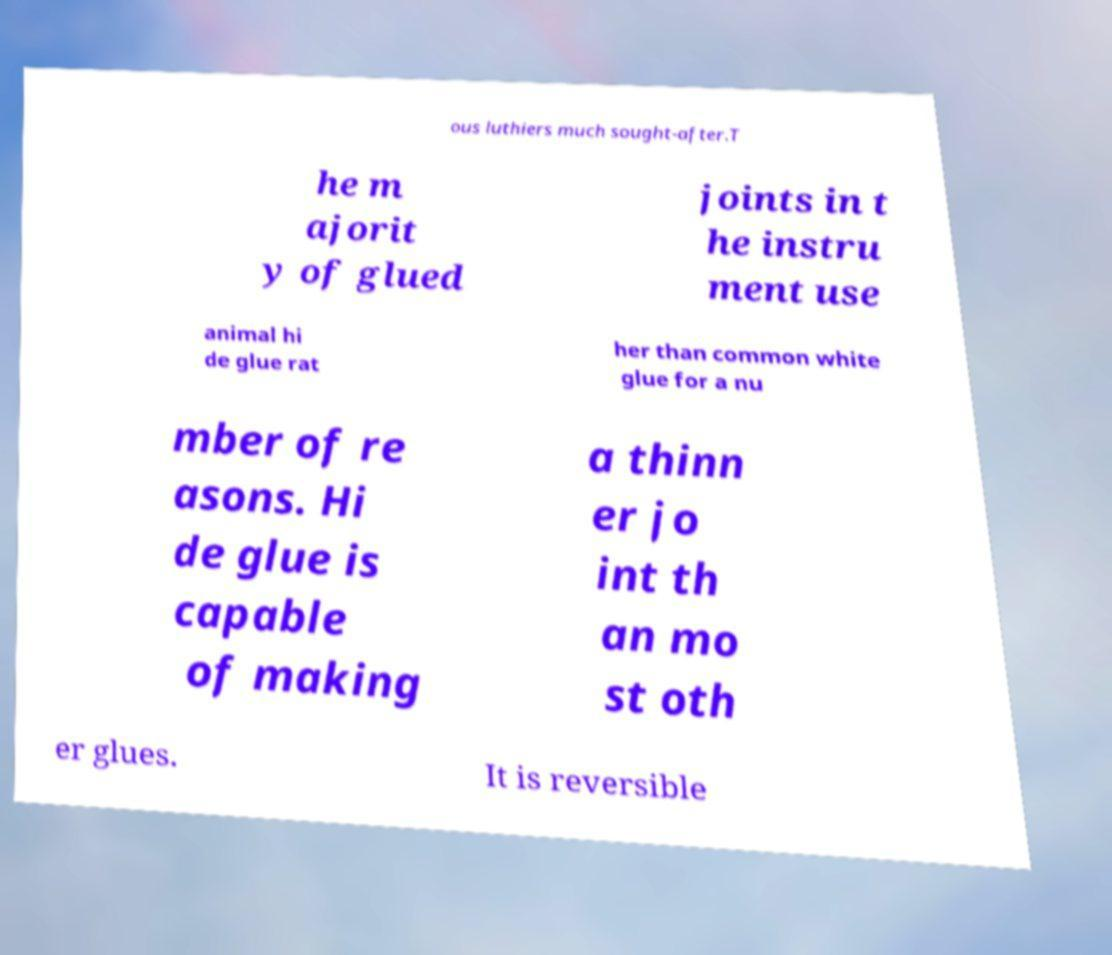Please identify and transcribe the text found in this image. ous luthiers much sought-after.T he m ajorit y of glued joints in t he instru ment use animal hi de glue rat her than common white glue for a nu mber of re asons. Hi de glue is capable of making a thinn er jo int th an mo st oth er glues. It is reversible 